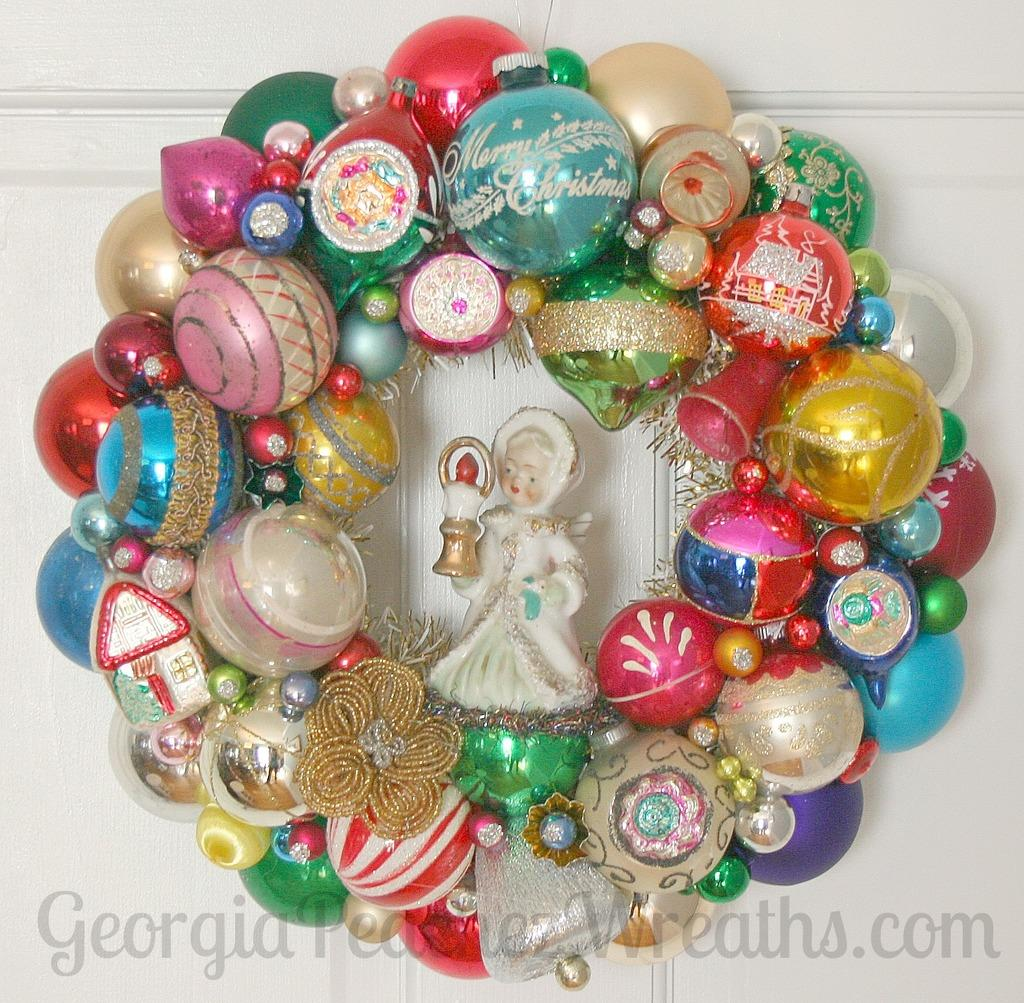What is the main subject in the center of the image? There is a doll in the center of the image. What other decorative items can be seen in the image? There are decorative balls and flowers in the image. What is visible in the background of the image? There is a wall in the background of the image. What is the size of the oranges on the wall in the image? There are no oranges present in the image; it features a doll, decorative balls, and flowers, along with a wall in the background. 